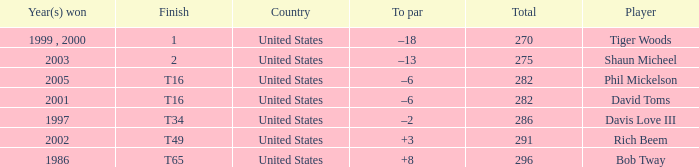In what place did Phil Mickelson finish with a total of 282? T16. 